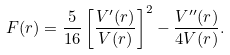<formula> <loc_0><loc_0><loc_500><loc_500>F ( r ) = \frac { 5 } { 1 6 } \left [ \frac { V ^ { \prime } ( r ) } { V ( r ) } \right ] ^ { 2 } - \frac { V ^ { \prime \prime } ( r ) } { 4 V ( r ) } .</formula> 